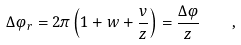Convert formula to latex. <formula><loc_0><loc_0><loc_500><loc_500>\Delta \varphi _ { r } = 2 \pi \left ( 1 + w + \frac { v } { z } \right ) = \frac { \Delta \varphi } { z } \quad ,</formula> 